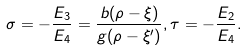<formula> <loc_0><loc_0><loc_500><loc_500>\sigma = - \frac { E _ { 3 } } { E _ { 4 } } = \frac { b ( \rho - \xi ) } { g ( \rho - \xi ^ { \prime } ) } , \tau = - \frac { E _ { 2 } } { E _ { 4 } } .</formula> 